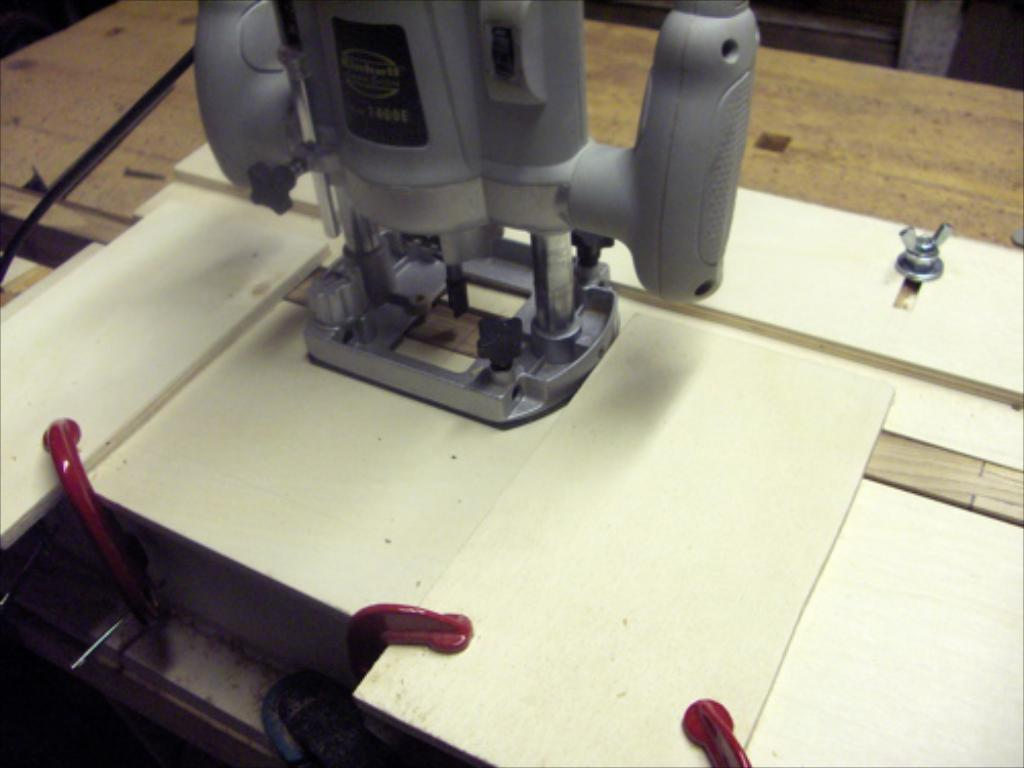What is the main object in the image? There is a machine in the image. Where is the machine located? The machine is on a table. What type of ornament is hanging from the machine in the image? There is no ornament hanging from the machine in the image; only the machine and the table are present. 